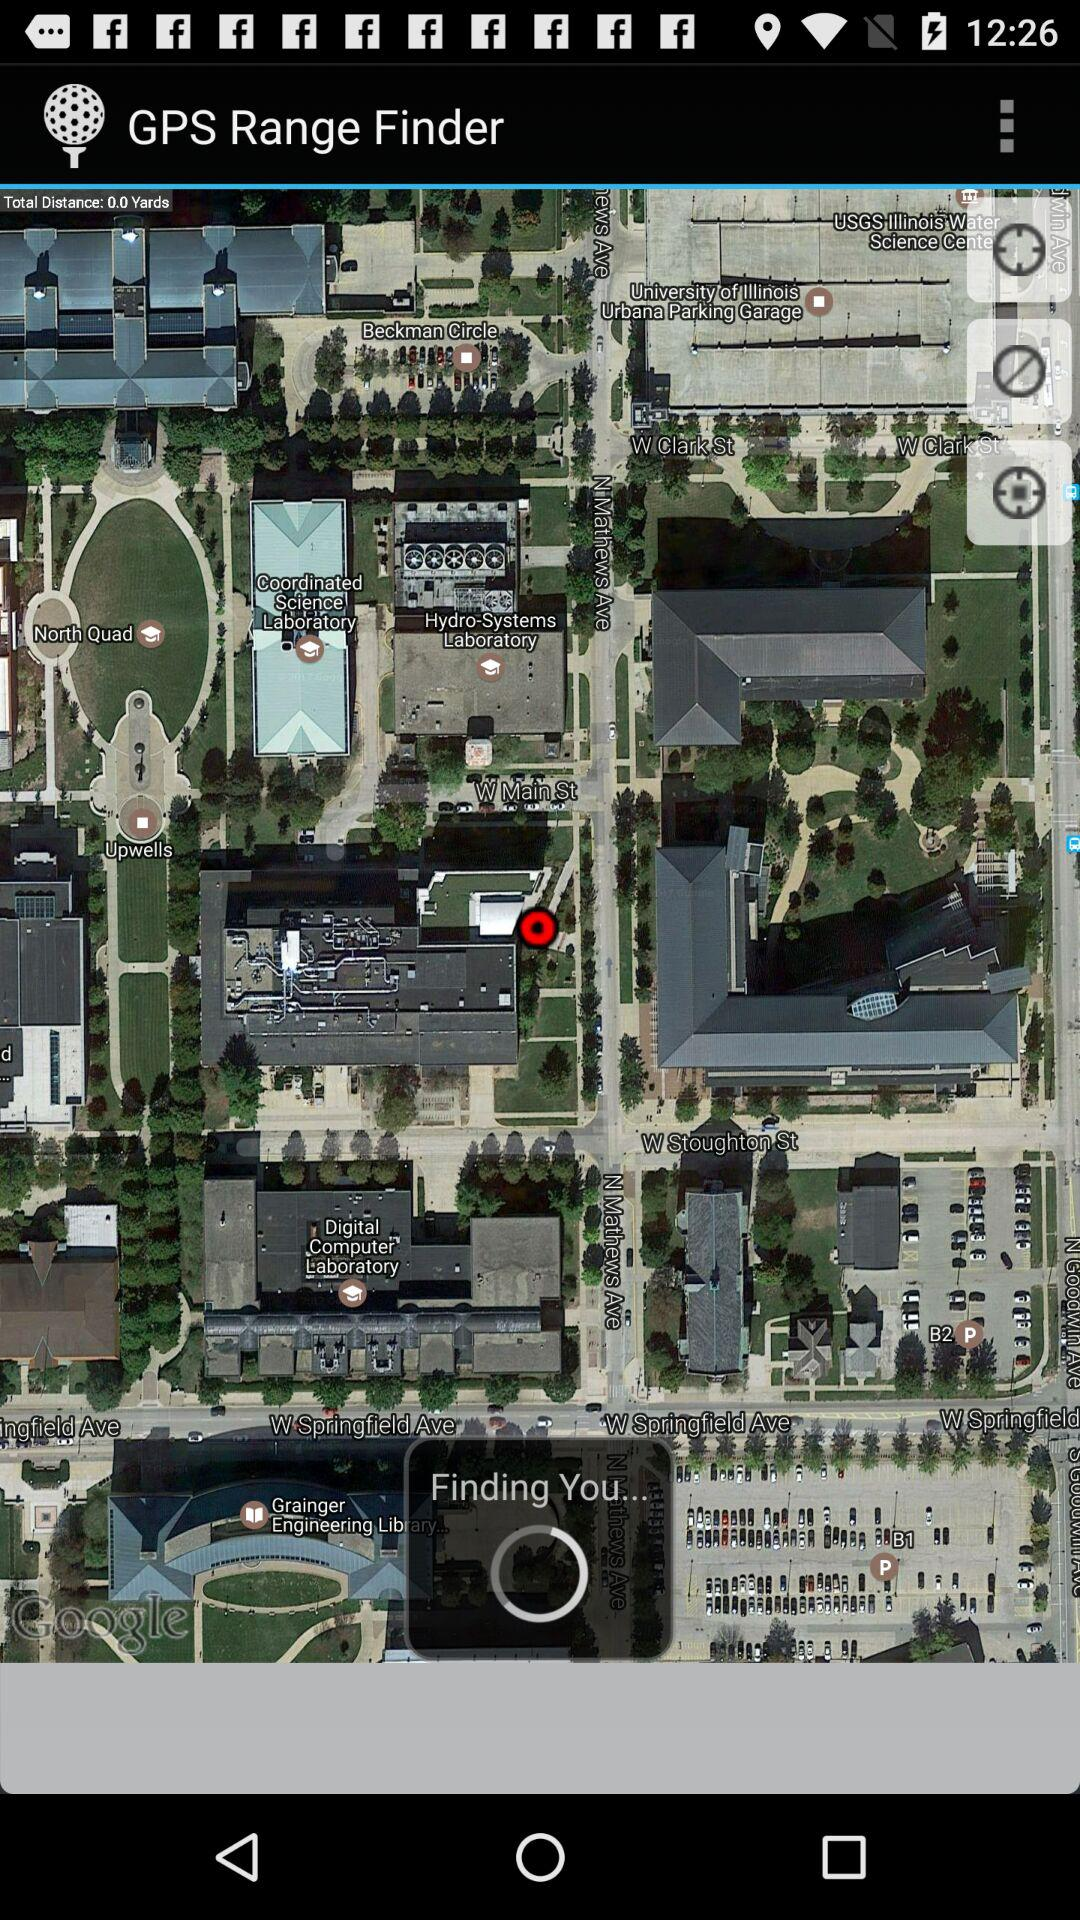What is the application name? The application name is "GPS Range Finder". 